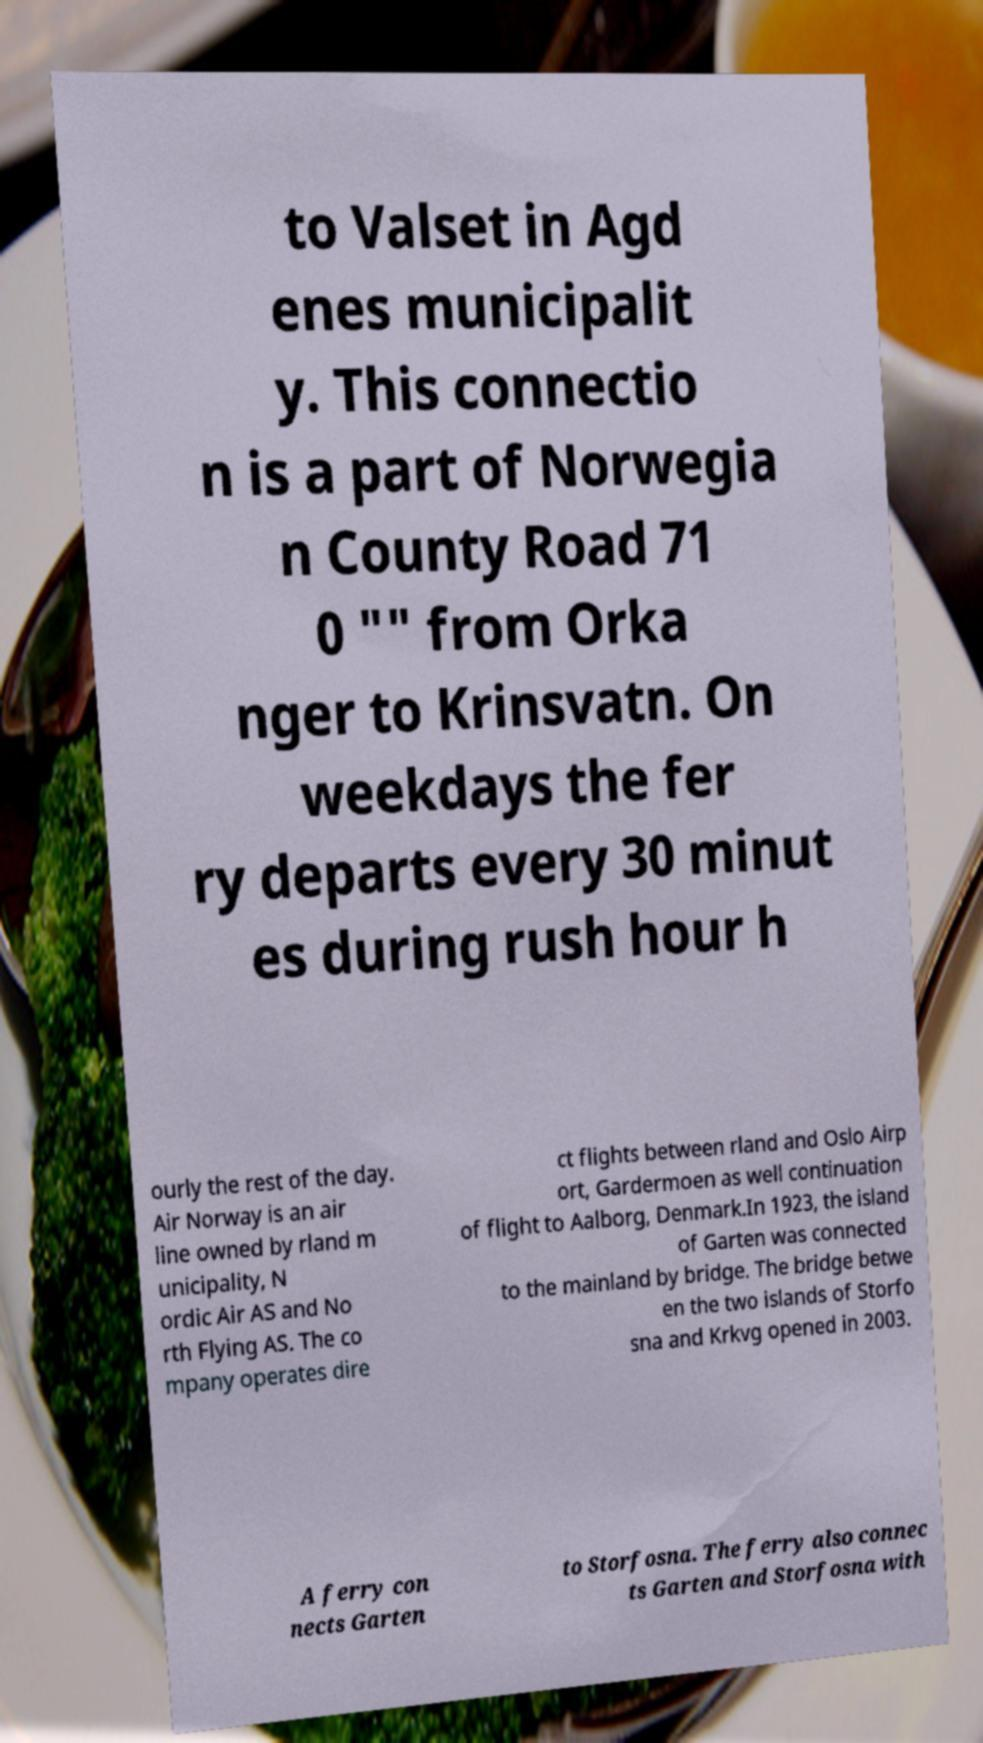Please read and relay the text visible in this image. What does it say? to Valset in Agd enes municipalit y. This connectio n is a part of Norwegia n County Road 71 0 "" from Orka nger to Krinsvatn. On weekdays the fer ry departs every 30 minut es during rush hour h ourly the rest of the day. Air Norway is an air line owned by rland m unicipality, N ordic Air AS and No rth Flying AS. The co mpany operates dire ct flights between rland and Oslo Airp ort, Gardermoen as well continuation of flight to Aalborg, Denmark.In 1923, the island of Garten was connected to the mainland by bridge. The bridge betwe en the two islands of Storfo sna and Krkvg opened in 2003. A ferry con nects Garten to Storfosna. The ferry also connec ts Garten and Storfosna with 